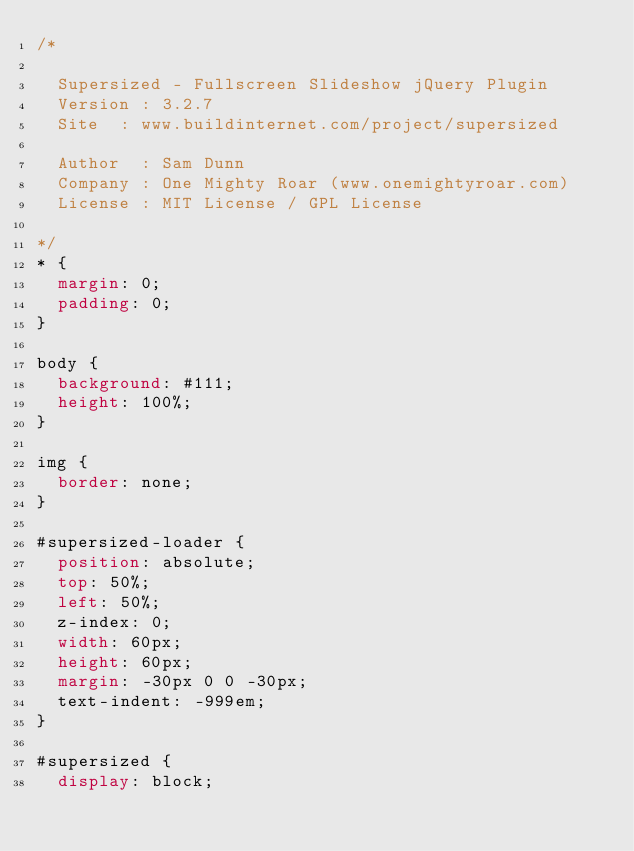<code> <loc_0><loc_0><loc_500><loc_500><_CSS_>/*

	Supersized - Fullscreen Slideshow jQuery Plugin
	Version : 3.2.7
	Site	: www.buildinternet.com/project/supersized
	
	Author	: Sam Dunn
	Company : One Mighty Roar (www.onemightyroar.com)
	License : MIT License / GPL License
	
*/
* {
  margin: 0;
  padding: 0;
}

body {
  background: #111;
  height: 100%;
}

img {
  border: none;
}

#supersized-loader {
  position: absolute;
  top: 50%;
  left: 50%;
  z-index: 0;
  width: 60px;
  height: 60px;
  margin: -30px 0 0 -30px;
  text-indent: -999em;
}

#supersized {
  display: block;</code> 